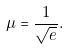Convert formula to latex. <formula><loc_0><loc_0><loc_500><loc_500>\mu = \frac { 1 } { \sqrt { e } } .</formula> 